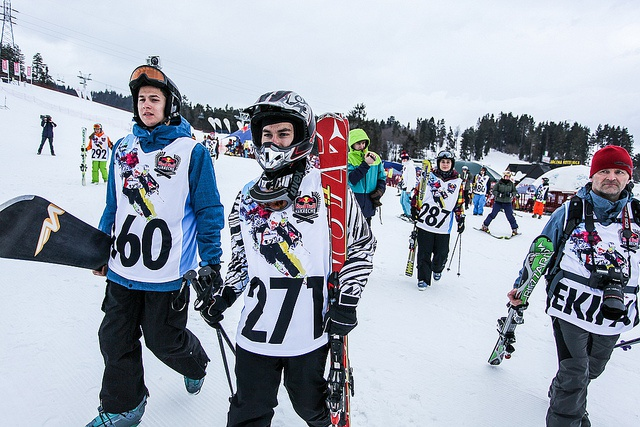Describe the objects in this image and their specific colors. I can see people in lavender, black, gray, and darkgray tones, people in lavender, black, blue, and navy tones, people in lavender, black, and blue tones, snowboard in lavender, black, lightgray, and darkblue tones, and people in lavender, black, gray, and darkgray tones in this image. 